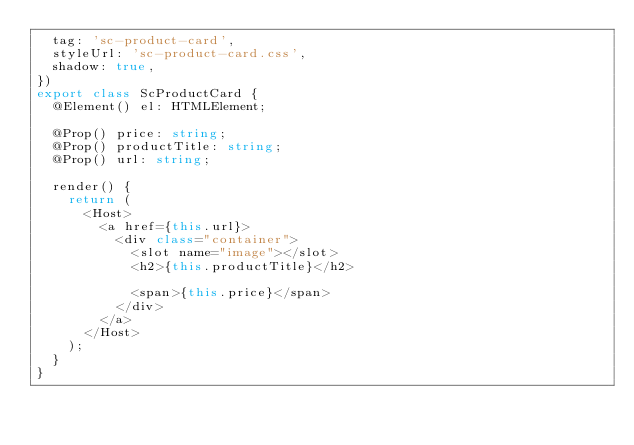Convert code to text. <code><loc_0><loc_0><loc_500><loc_500><_TypeScript_>  tag: 'sc-product-card',
  styleUrl: 'sc-product-card.css',
  shadow: true,
})
export class ScProductCard {
  @Element() el: HTMLElement;

  @Prop() price: string;
  @Prop() productTitle: string;
  @Prop() url: string;

  render() {
    return (
      <Host>
        <a href={this.url}>
          <div class="container">
            <slot name="image"></slot>
            <h2>{this.productTitle}</h2>

            <span>{this.price}</span>
          </div>
        </a>
      </Host>
    );
  }
}
</code> 